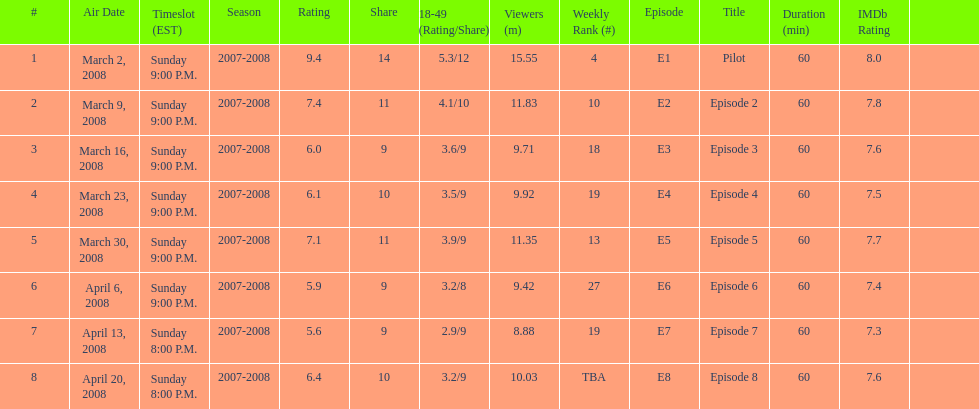What time slot did the show have for its first 6 episodes? Sunday 9:00 P.M. 